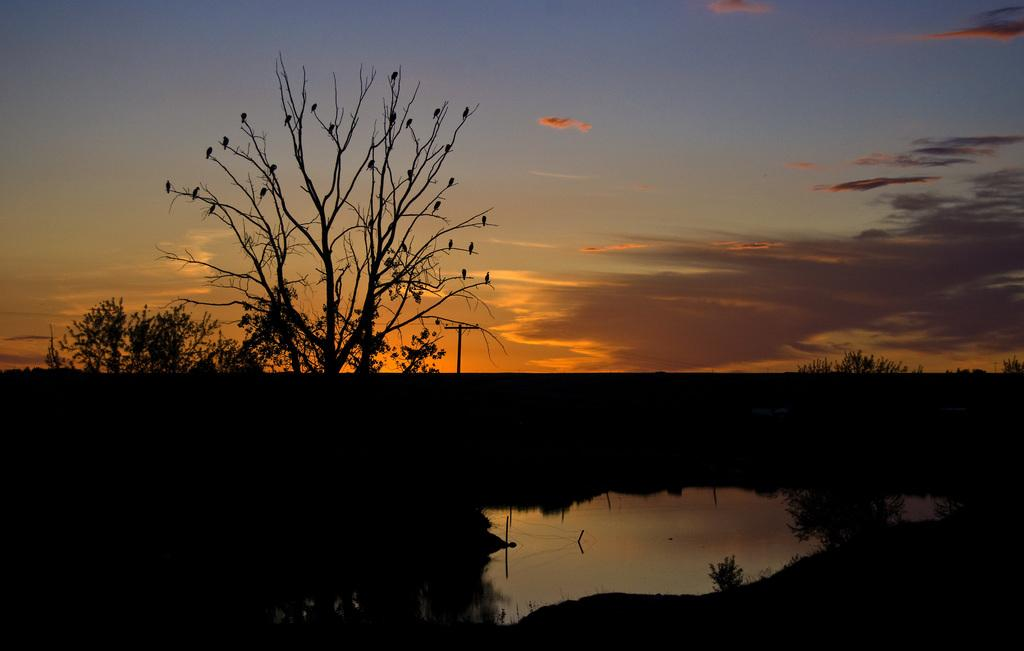What type of natural elements can be seen in the image? There are trees and water visible in the image. What man-made object is present in the image? There is an electrical pole in the image. How would you describe the sky in the image? The sky is blue and cloudy in the image. Can you see any sunlight in the image? Yes, sunlight is visible in the image. What type of light is the partner holding in the image? There is no partner or light present in the image. How many dolls are sitting on the branches of the trees in the image? There are no dolls present in the image; it features trees, water, an electrical pole, and a blue and cloudy sky. 